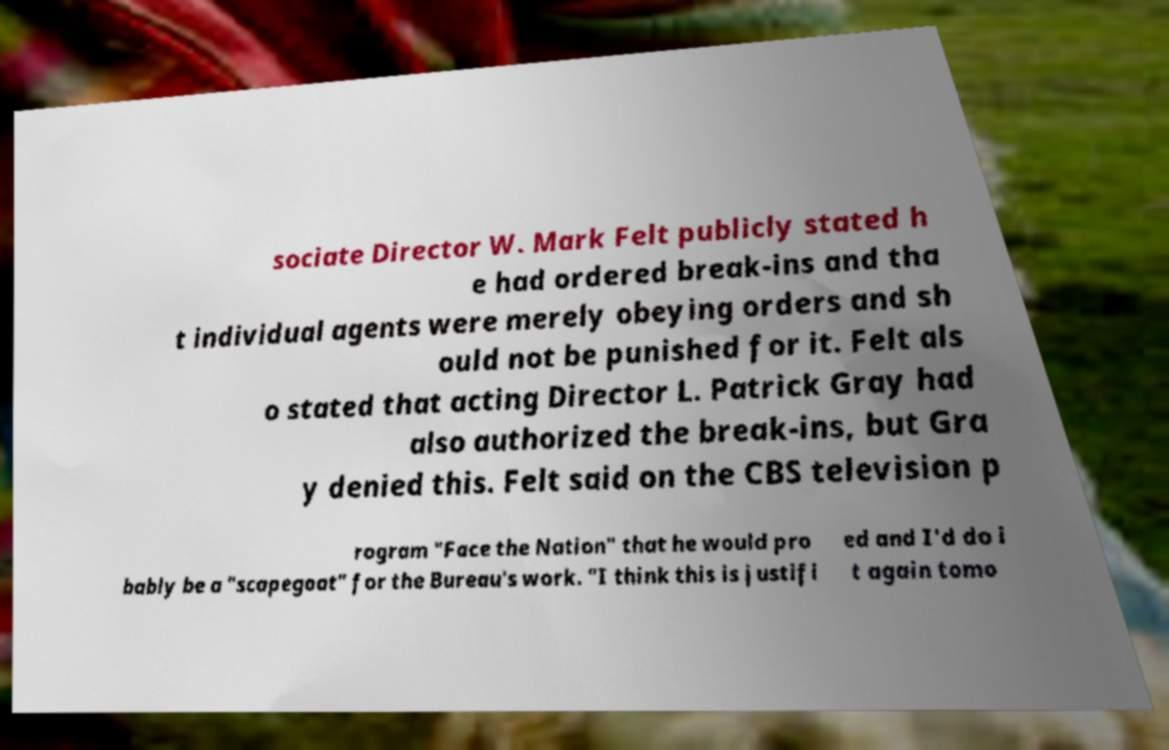Please read and relay the text visible in this image. What does it say? sociate Director W. Mark Felt publicly stated h e had ordered break-ins and tha t individual agents were merely obeying orders and sh ould not be punished for it. Felt als o stated that acting Director L. Patrick Gray had also authorized the break-ins, but Gra y denied this. Felt said on the CBS television p rogram "Face the Nation" that he would pro bably be a "scapegoat" for the Bureau's work. "I think this is justifi ed and I'd do i t again tomo 